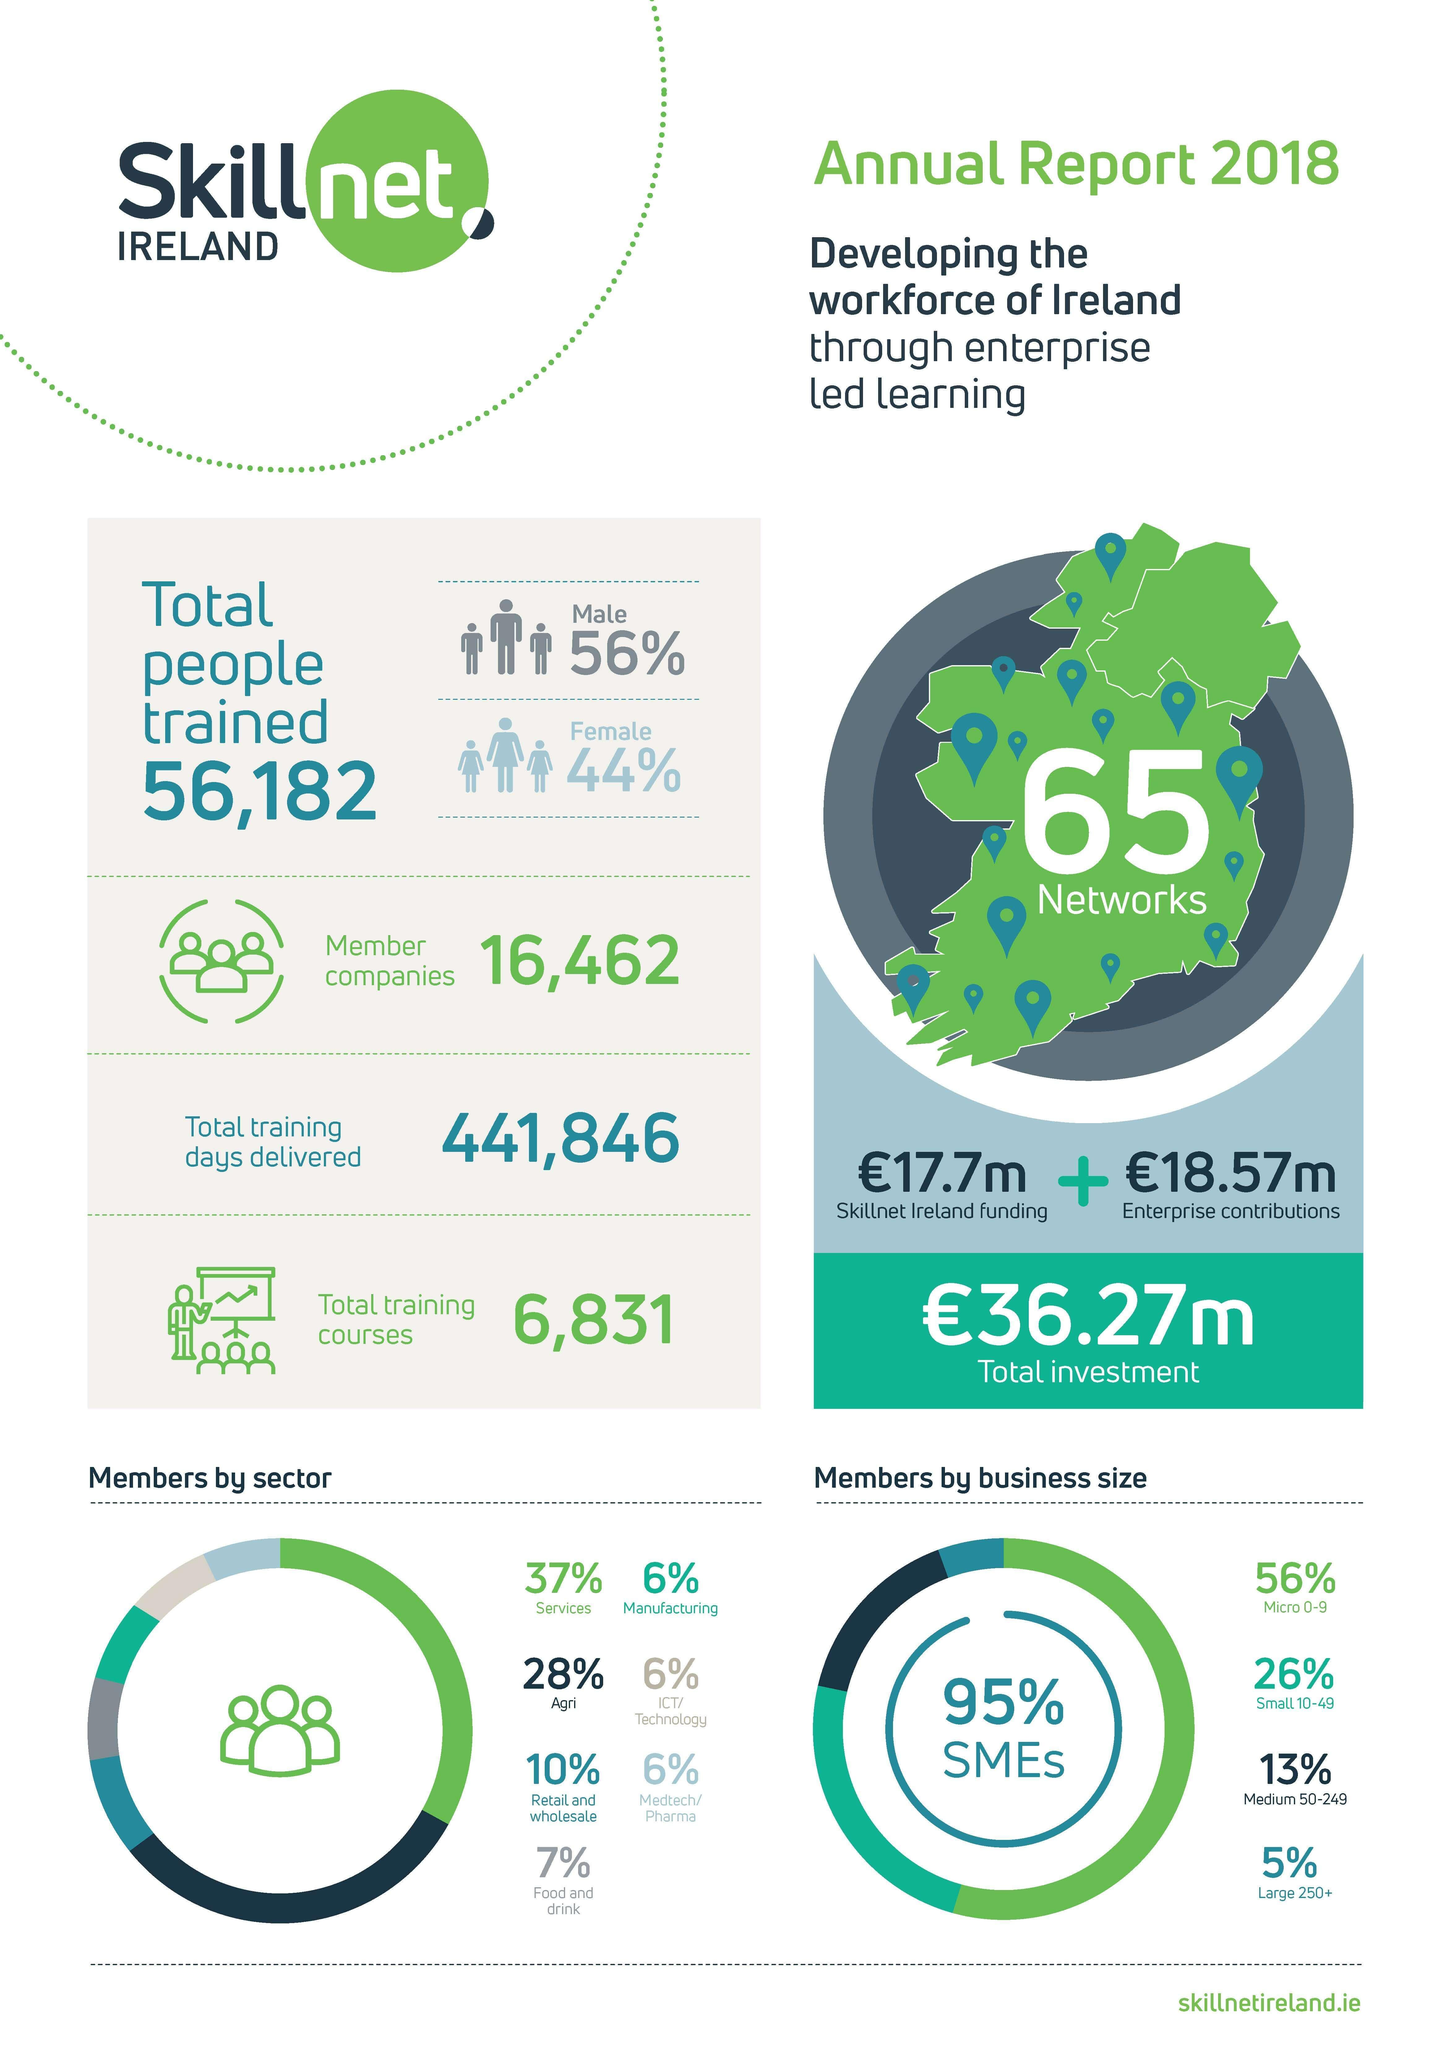what percent of members are doing large or medium scale businesses?
Answer the question with a short phrase. 18% what is the total percentage of members from services and agriculture sectors? 65% what is the source of smaller share of total investment? skillnet Ireland funding what percent of members are doing small or medium scale businesses? 39 Which sectors have the same percentage of members? manufacturing, ICT/technology, medtech/pharma what is the source of larger share of total investment? enterprise contributions what percent of members are doing small or micro scale businesses? 86% Which trainees are more - male or female? male what is the total percentage of members who are not from services, agriculture or retail and wholesale sectors? 25 Which sector has the majority members? services what is the total percentage of members from food and drink and agriculture sectors? 35% what is the total percentage of members from food and drink and pharma/medtechl sectors? 13% 